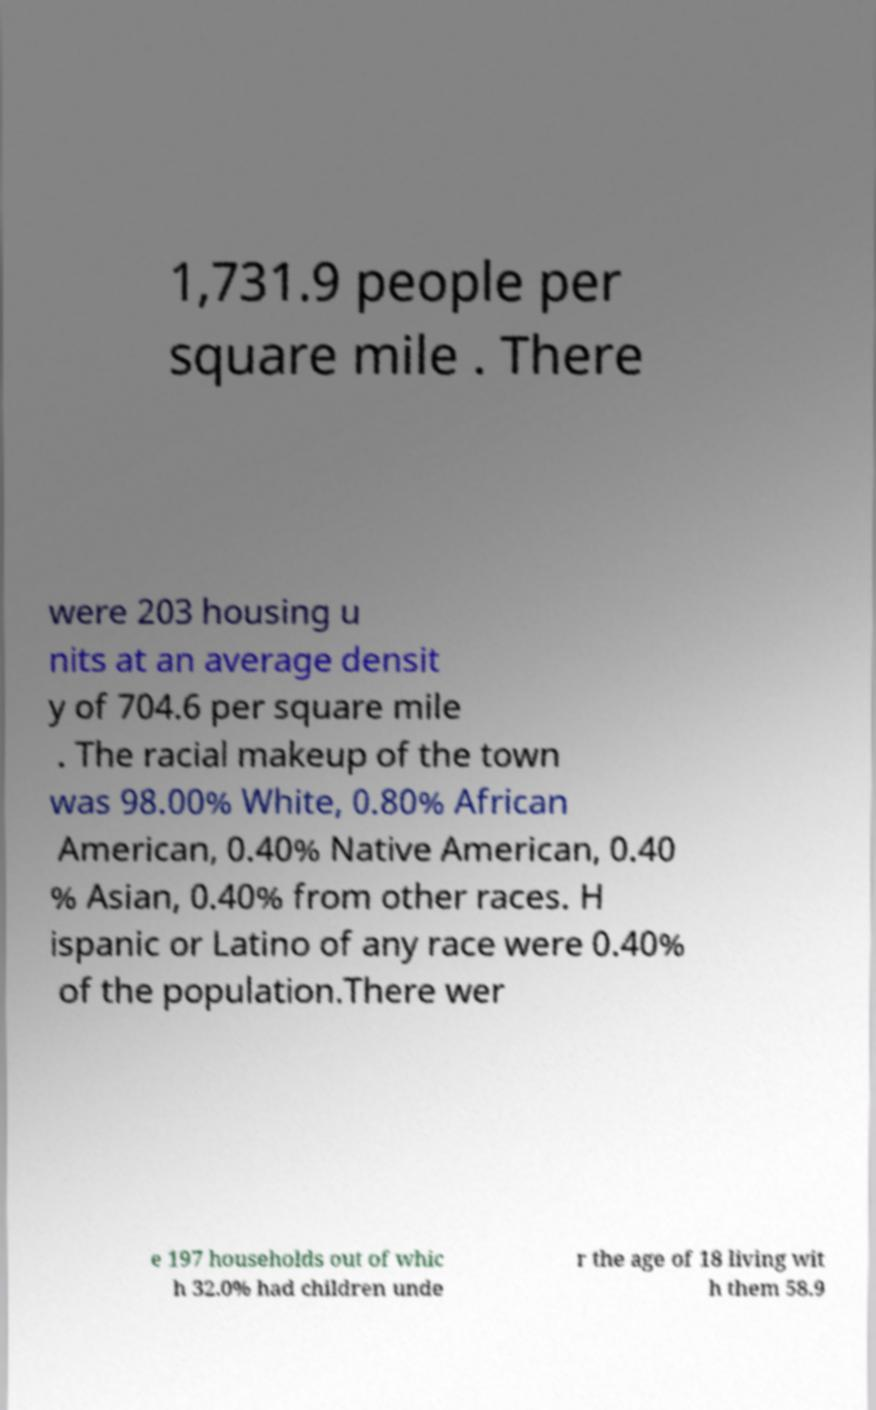Can you read and provide the text displayed in the image?This photo seems to have some interesting text. Can you extract and type it out for me? 1,731.9 people per square mile . There were 203 housing u nits at an average densit y of 704.6 per square mile . The racial makeup of the town was 98.00% White, 0.80% African American, 0.40% Native American, 0.40 % Asian, 0.40% from other races. H ispanic or Latino of any race were 0.40% of the population.There wer e 197 households out of whic h 32.0% had children unde r the age of 18 living wit h them 58.9 